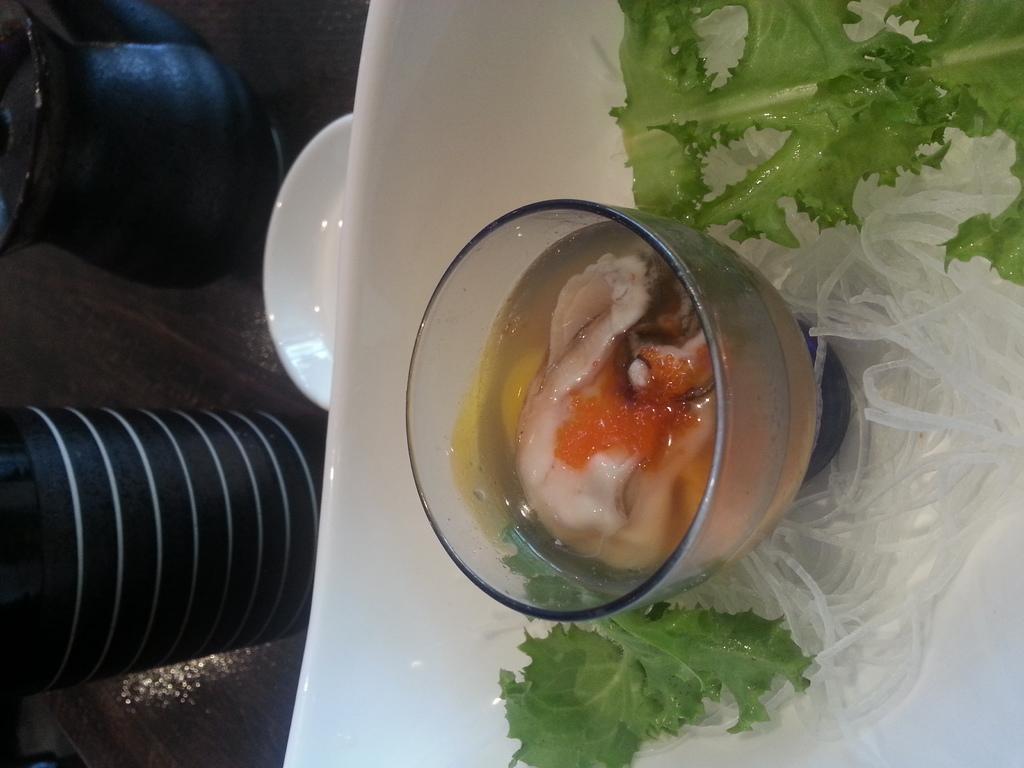Describe this image in one or two sentences. In this image, we can see some food, bowl with edible items are placed on a white surface. On the left side of the image, we can see container, jug and bowl. Here we can see wooden object. 